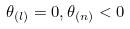Convert formula to latex. <formula><loc_0><loc_0><loc_500><loc_500>\theta _ { ( l ) } = 0 , \theta _ { ( n ) } < 0</formula> 